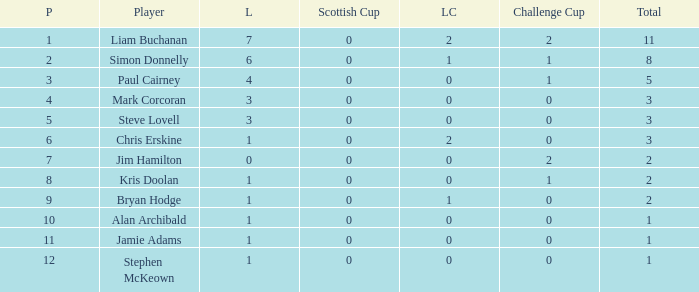What is bryan hodge's player number 1.0. 